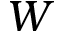Convert formula to latex. <formula><loc_0><loc_0><loc_500><loc_500>W</formula> 